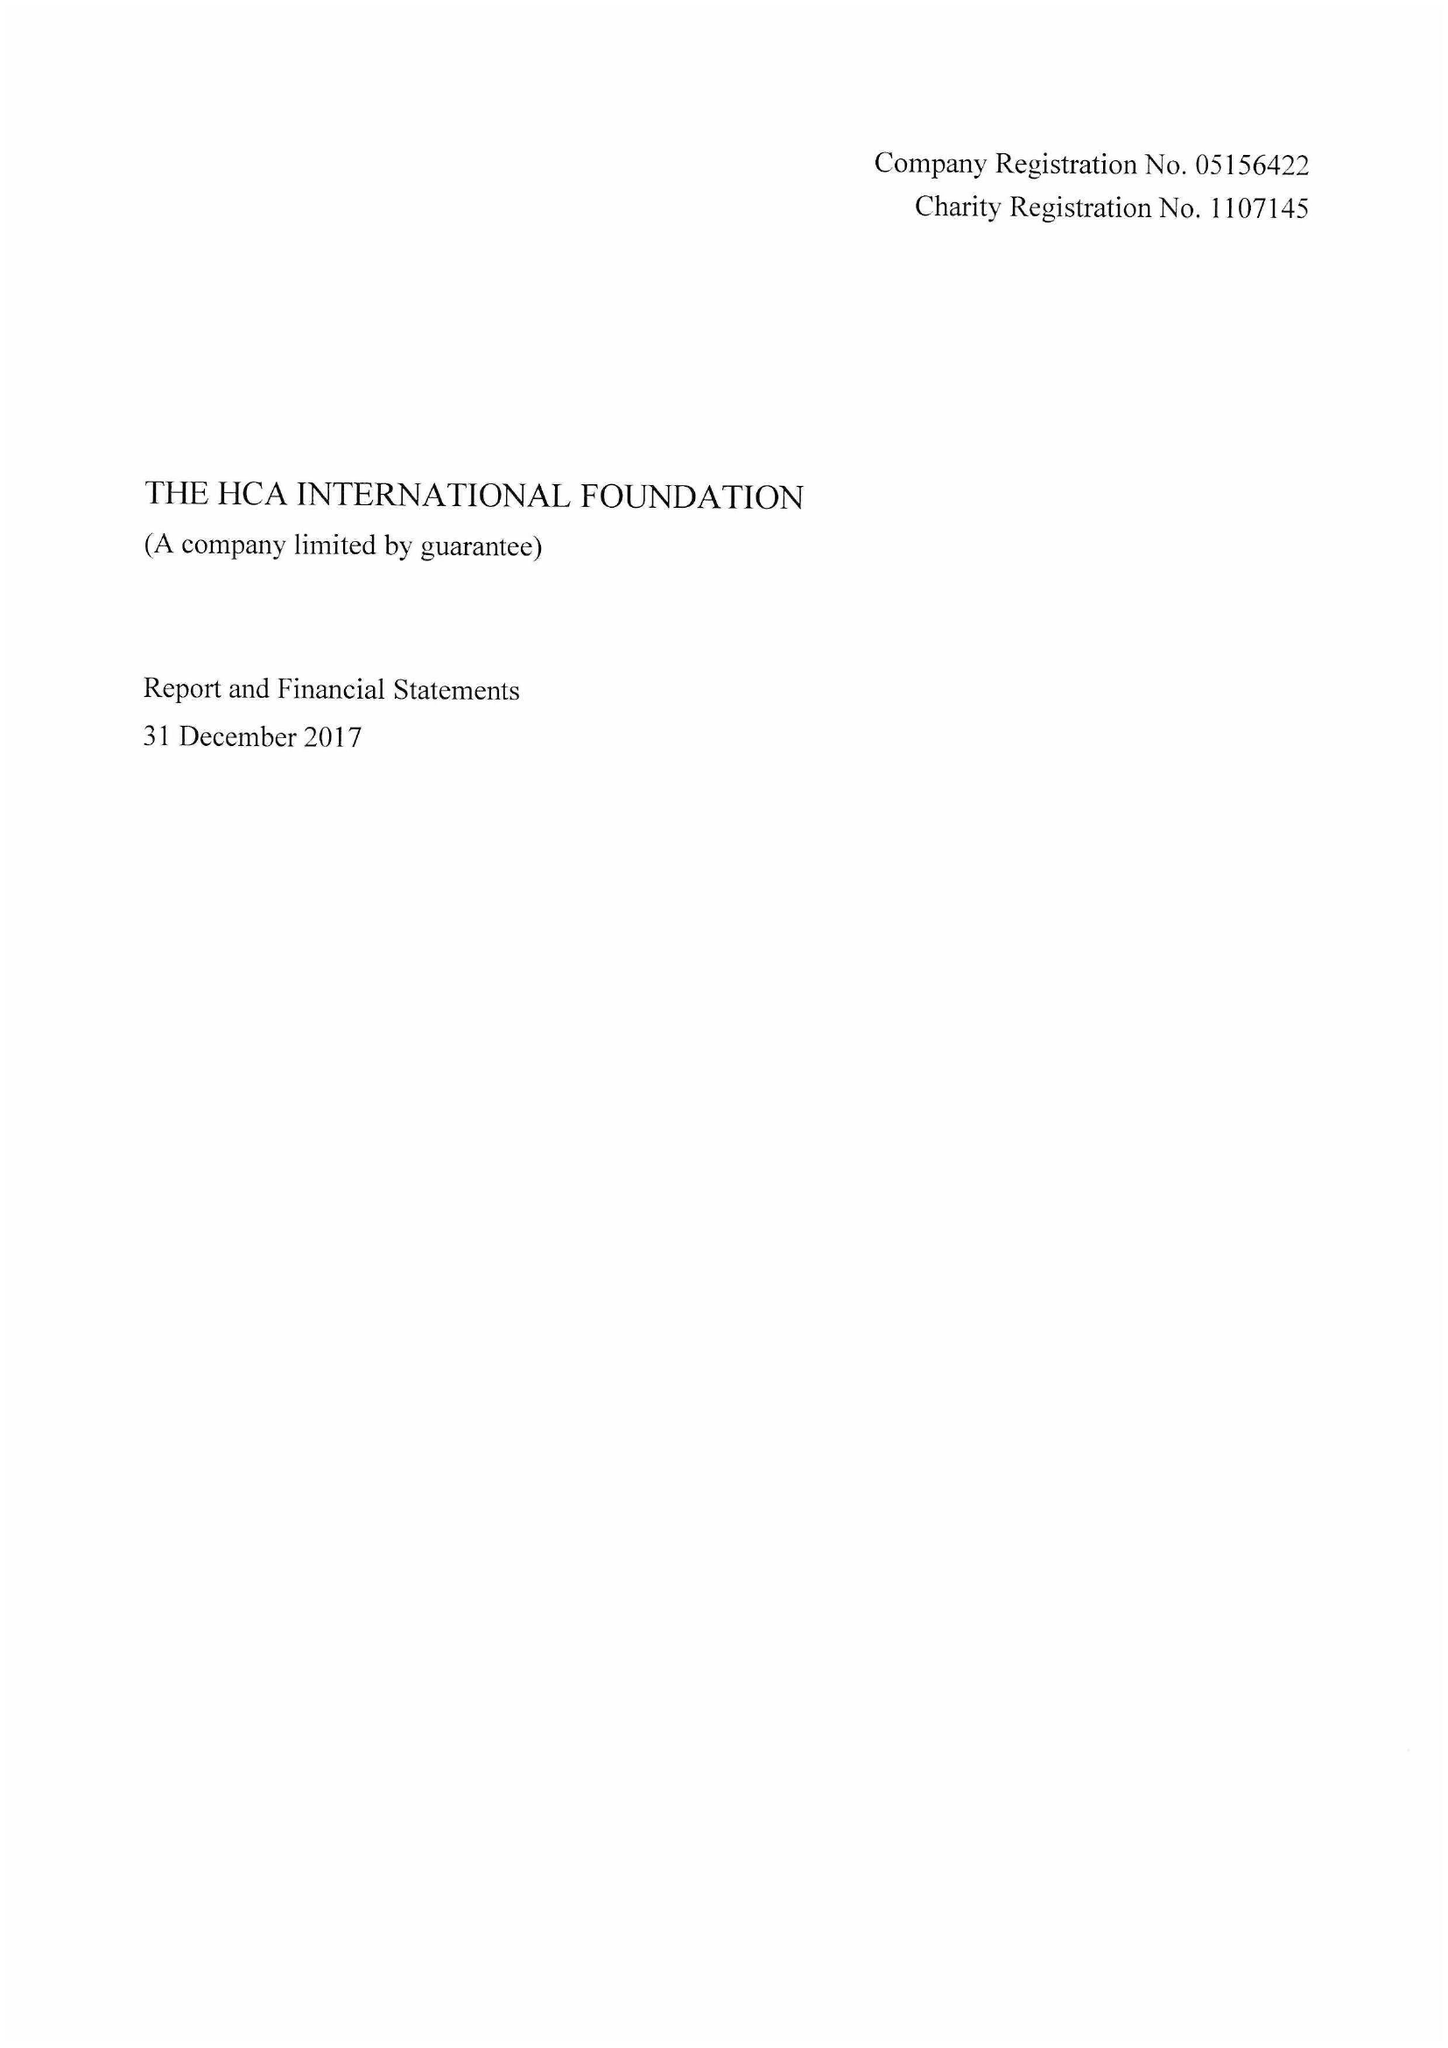What is the value for the spending_annually_in_british_pounds?
Answer the question using a single word or phrase. 92454.00 